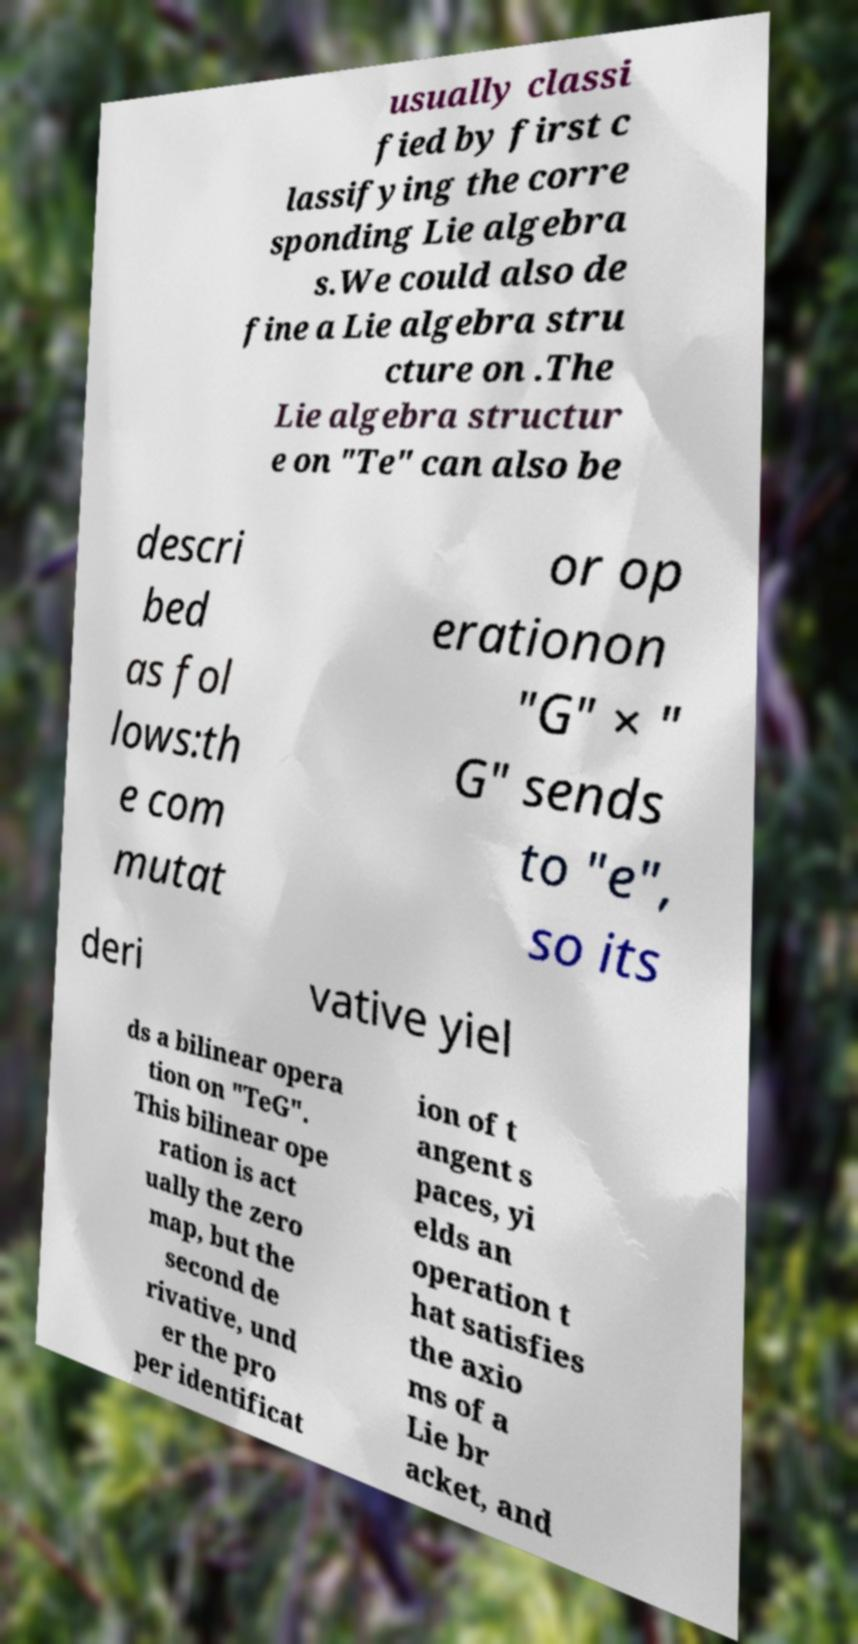Can you read and provide the text displayed in the image?This photo seems to have some interesting text. Can you extract and type it out for me? usually classi fied by first c lassifying the corre sponding Lie algebra s.We could also de fine a Lie algebra stru cture on .The Lie algebra structur e on "Te" can also be descri bed as fol lows:th e com mutat or op erationon "G" × " G" sends to "e", so its deri vative yiel ds a bilinear opera tion on "TeG". This bilinear ope ration is act ually the zero map, but the second de rivative, und er the pro per identificat ion of t angent s paces, yi elds an operation t hat satisfies the axio ms of a Lie br acket, and 